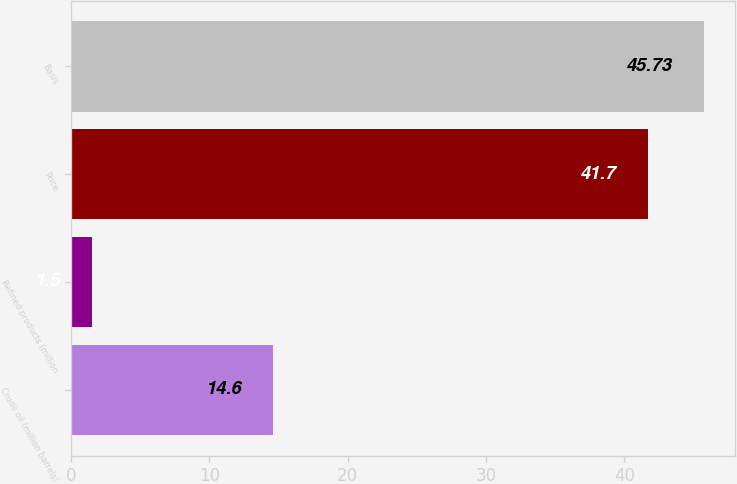Convert chart to OTSL. <chart><loc_0><loc_0><loc_500><loc_500><bar_chart><fcel>Crude oil (million barrels)<fcel>Refined products (million<fcel>Price<fcel>Basis<nl><fcel>14.6<fcel>1.5<fcel>41.7<fcel>45.73<nl></chart> 